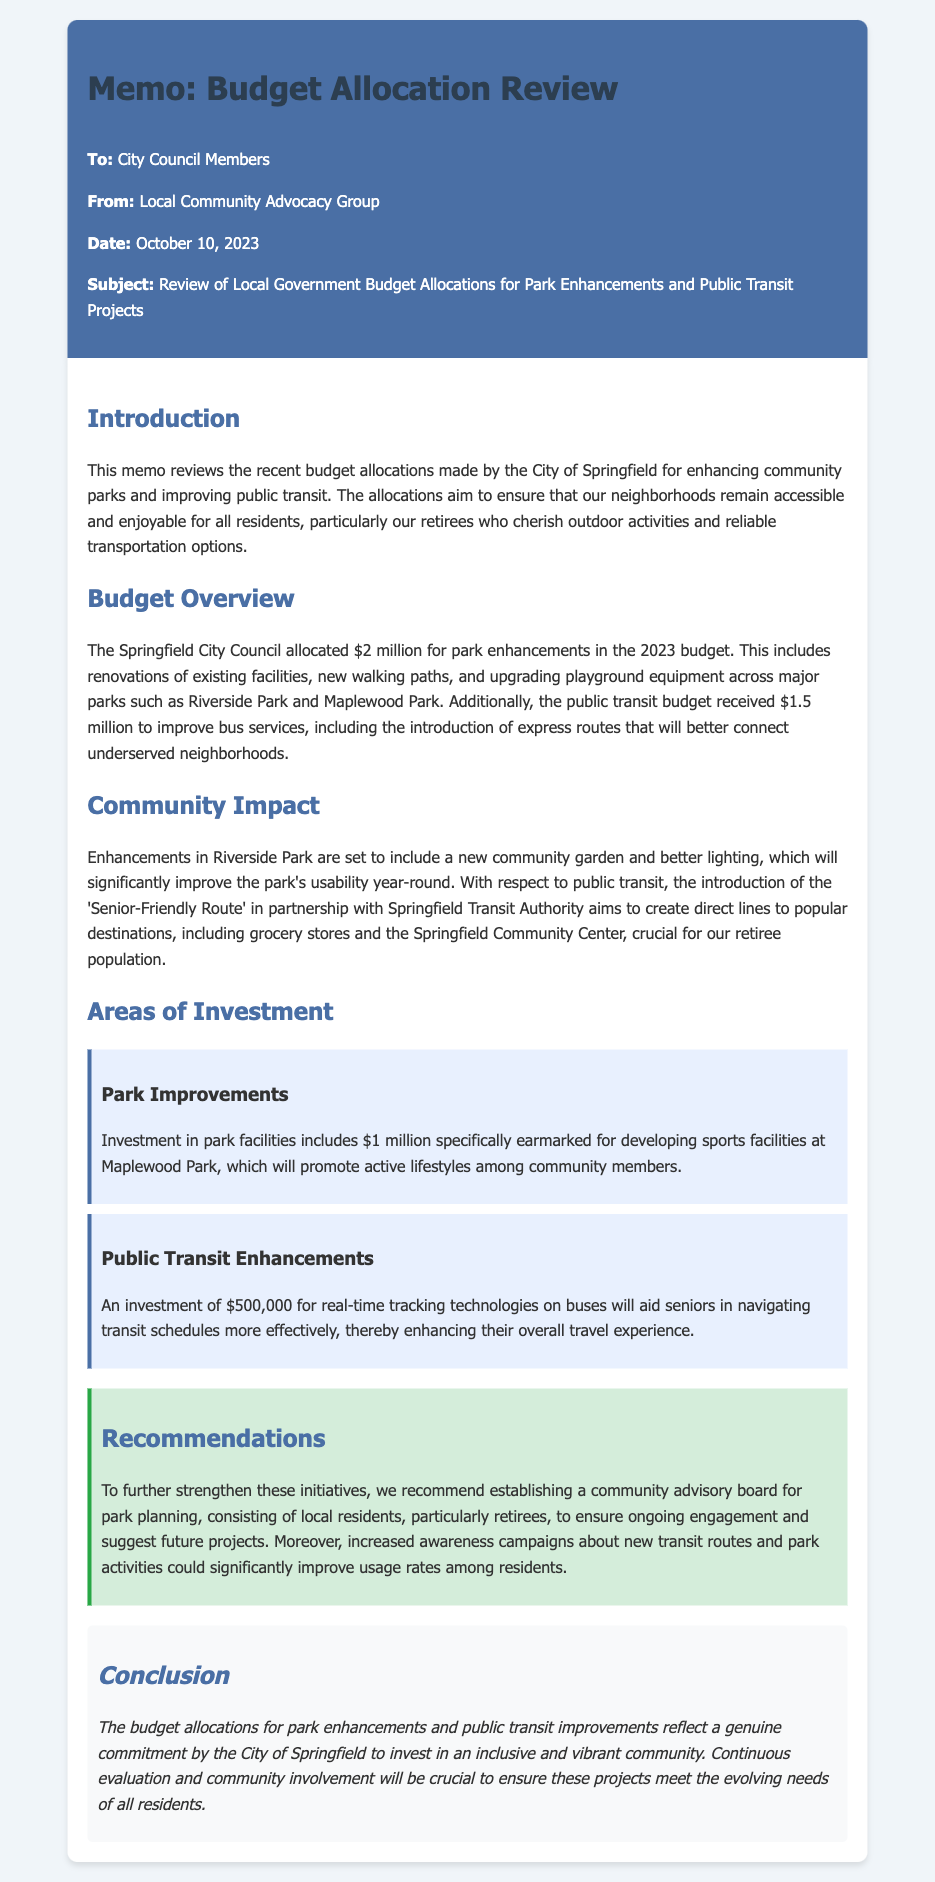what is the total allocation for park enhancements? The total allocation for park enhancements in the 2023 budget is stated directly in the budget overview section, which is $2 million.
Answer: $2 million how much is allocated for public transit improvements? The allocation for public transit improvements is mentioned in the budget overview, which is $1.5 million.
Answer: $1.5 million what specific feature is included in the enhancements for Riverside Park? The specific feature mentioned for Riverside Park improvements is better lighting.
Answer: better lighting what is the amount invested in real-time tracking technologies? The investment amount for real-time tracking technologies on buses is listed in the document, which is $500,000.
Answer: $500,000 what is the purpose of the 'Senior-Friendly Route'? The purpose of the 'Senior-Friendly Route' is to create direct lines to popular destinations for the retiree population.
Answer: create direct lines to popular destinations which park is receiving a million-dollar investment for developing sports facilities? The park that is receiving a million-dollar investment for developing sports facilities is identified in the areas of investment section as Maplewood Park.
Answer: Maplewood Park who is the memo addressed to? The memo is addressed to City Council Members, which is specified at the beginning of the document.
Answer: City Council Members what type of board is recommended for park planning? The type of board recommended for park planning is a community advisory board.
Answer: community advisory board what is the main conclusion of the memo? The main conclusion of the memo reflects a commitment to invest in an inclusive and vibrant community.
Answer: commitment to invest in an inclusive and vibrant community 